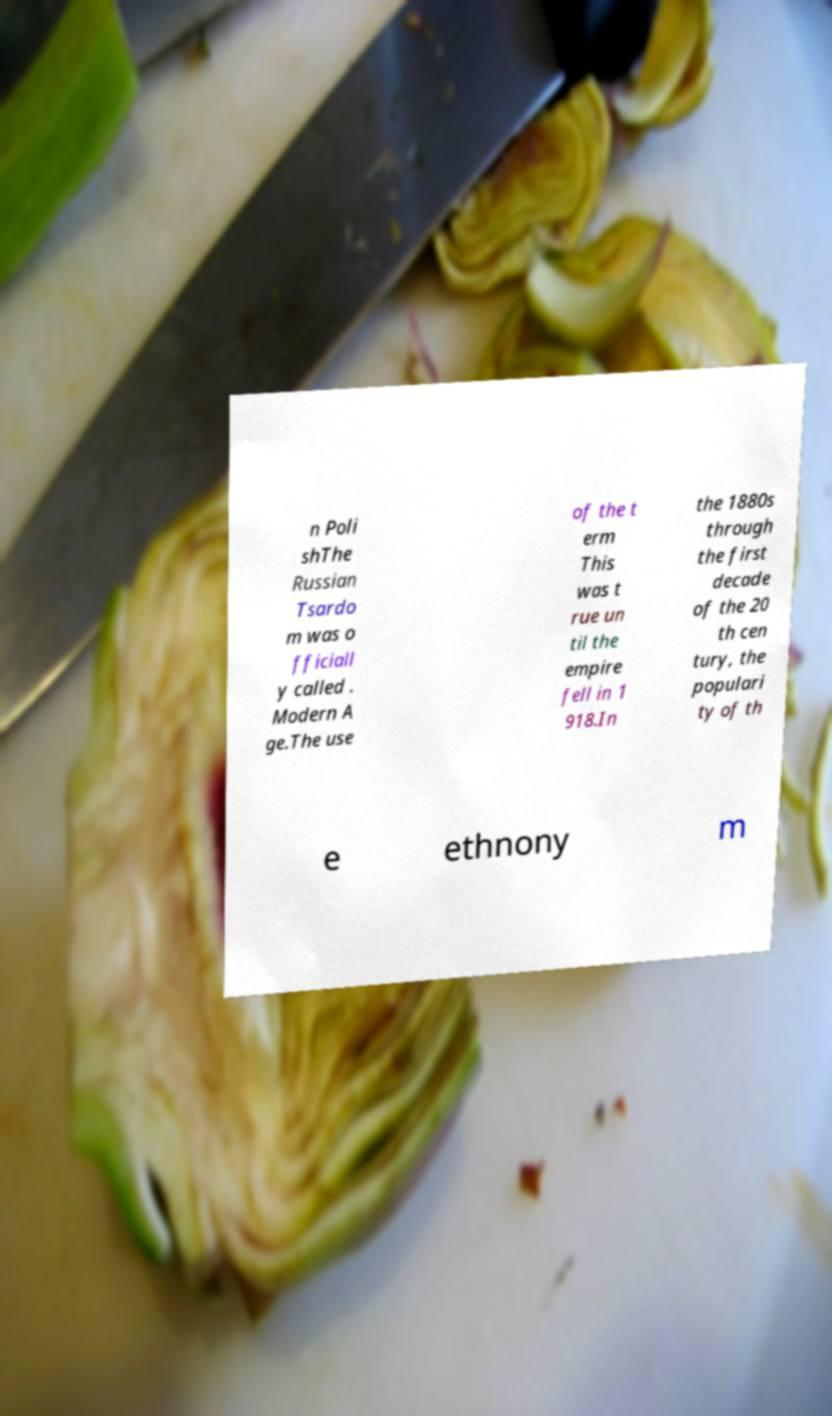For documentation purposes, I need the text within this image transcribed. Could you provide that? n Poli shThe Russian Tsardo m was o fficiall y called . Modern A ge.The use of the t erm This was t rue un til the empire fell in 1 918.In the 1880s through the first decade of the 20 th cen tury, the populari ty of th e ethnony m 